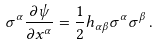<formula> <loc_0><loc_0><loc_500><loc_500>\sigma ^ { \alpha } \frac { \partial \psi } { \partial x ^ { \alpha } } = \frac { 1 } { 2 } { h } _ { \alpha \beta } \sigma ^ { \alpha } \sigma ^ { \beta } \, .</formula> 